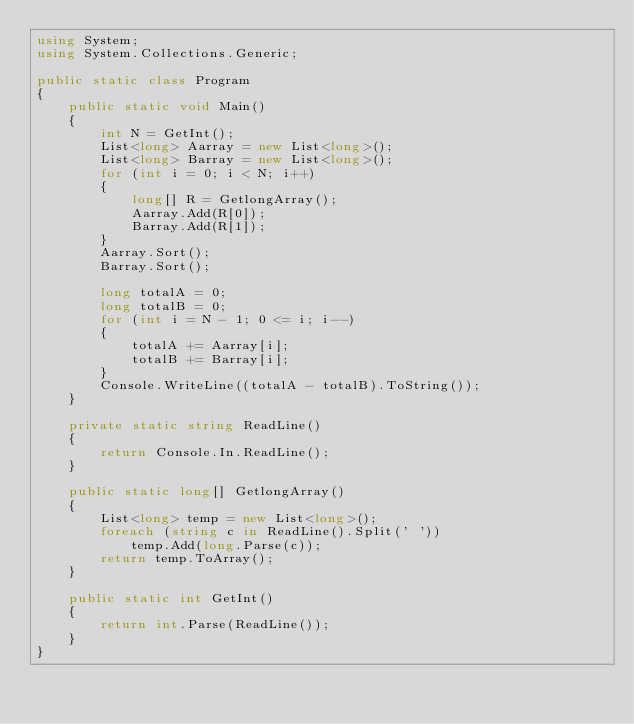Convert code to text. <code><loc_0><loc_0><loc_500><loc_500><_C#_>using System;
using System.Collections.Generic;
             
public static class Program
{
    public static void Main()
    {
        int N = GetInt();
        List<long> Aarray = new List<long>();
        List<long> Barray = new List<long>();
        for (int i = 0; i < N; i++)
        {
            long[] R = GetlongArray();
            Aarray.Add(R[0]);
            Barray.Add(R[1]);
        }
        Aarray.Sort();
        Barray.Sort();

        long totalA = 0;
        long totalB = 0;
        for (int i = N - 1; 0 <= i; i--)
        {
            totalA += Aarray[i];
            totalB += Barray[i];
        }
        Console.WriteLine((totalA - totalB).ToString());
    }
    
    private static string ReadLine()
    {
    	return Console.In.ReadLine();
    }
    
    public static long[] GetlongArray()
    {
    	List<long> temp = new List<long>();
    	foreach (string c in ReadLine().Split(' '))
            temp.Add(long.Parse(c));
        return temp.ToArray();
    }
    
    public static int GetInt()
    {
    	return int.Parse(ReadLine());
    }
}</code> 